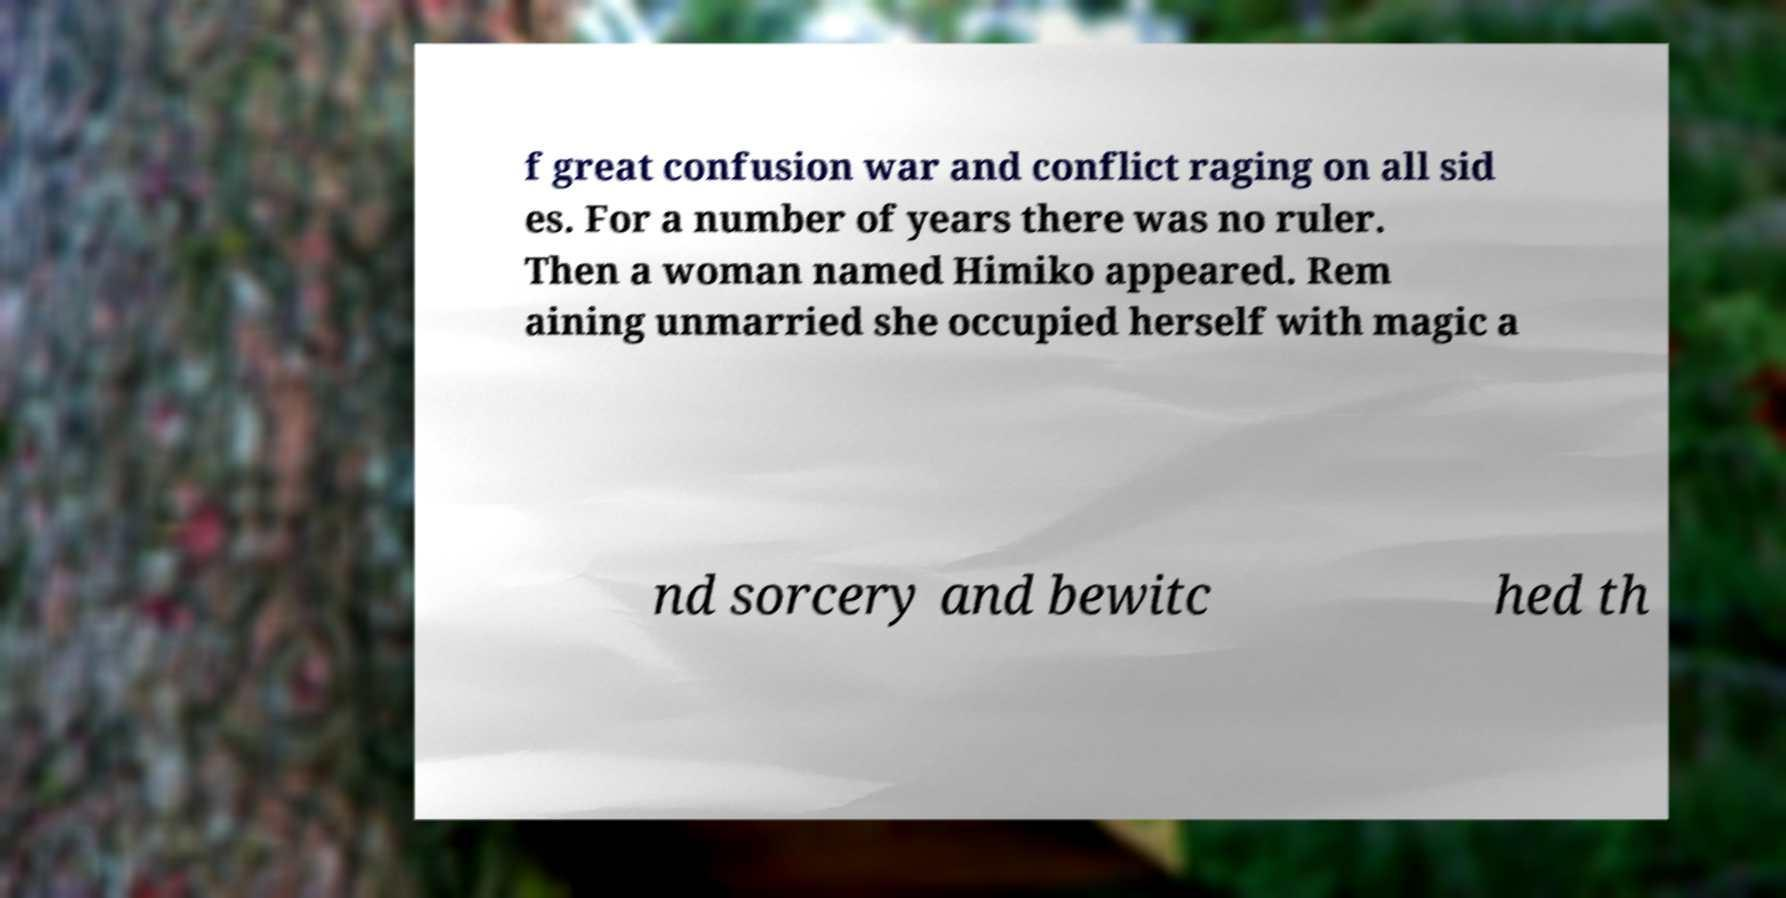Please read and relay the text visible in this image. What does it say? f great confusion war and conflict raging on all sid es. For a number of years there was no ruler. Then a woman named Himiko appeared. Rem aining unmarried she occupied herself with magic a nd sorcery and bewitc hed th 